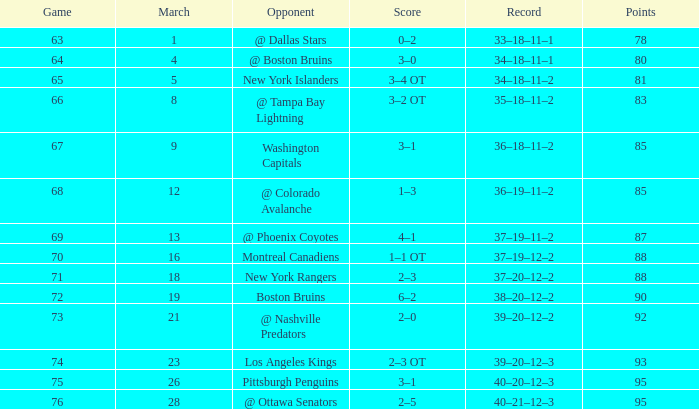Which Points have an Opponent of new york islanders, and a Game smaller than 65? None. 